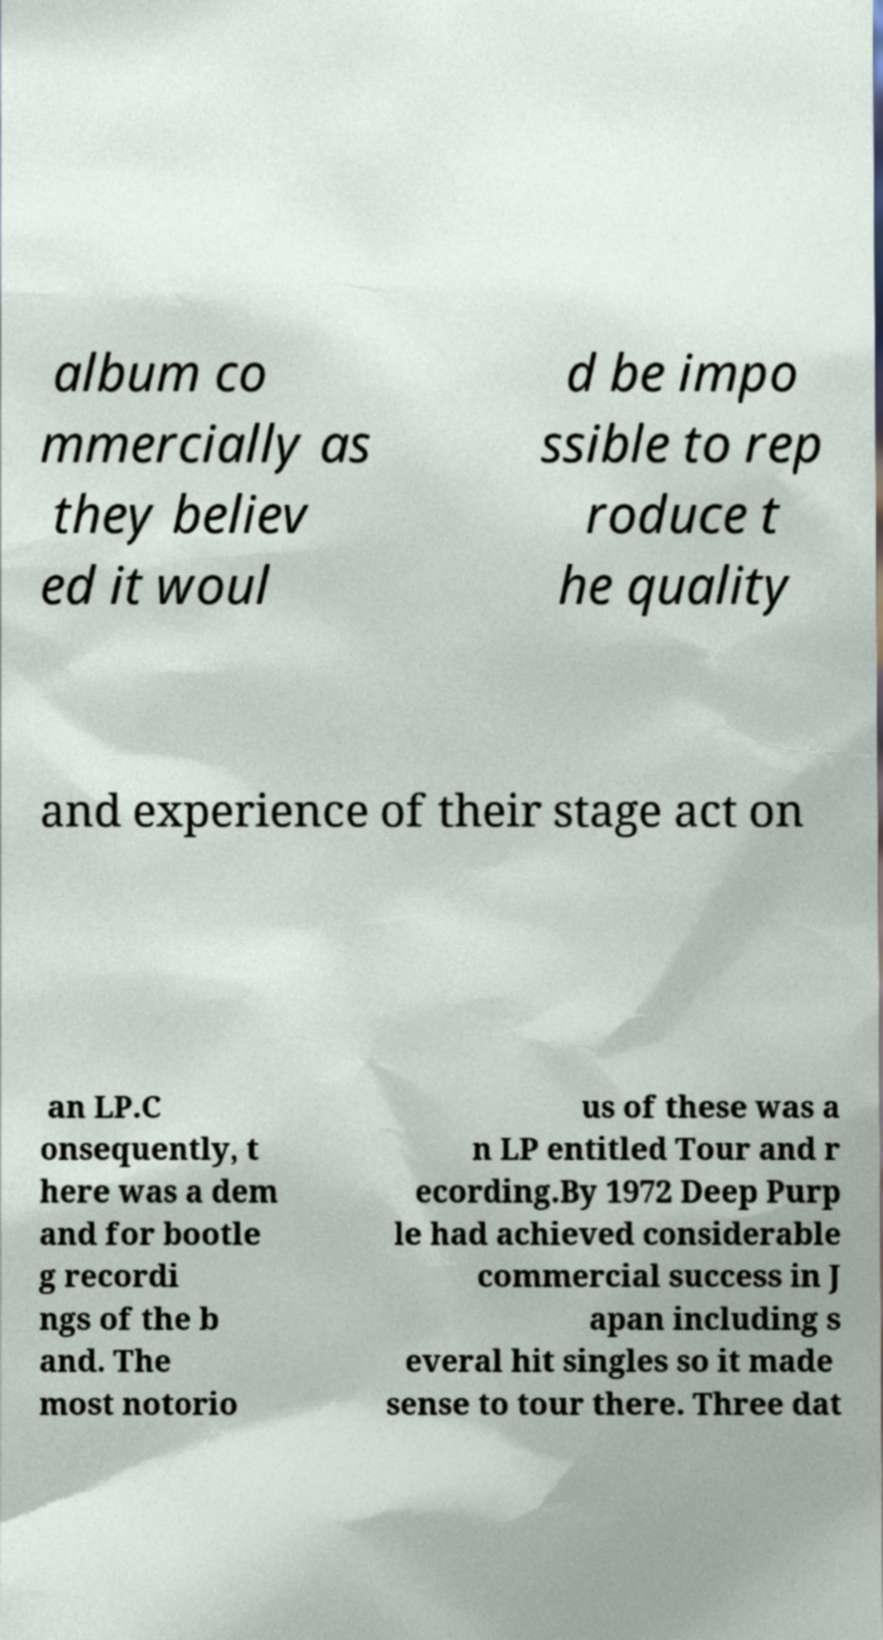Could you extract and type out the text from this image? album co mmercially as they believ ed it woul d be impo ssible to rep roduce t he quality and experience of their stage act on an LP.C onsequently, t here was a dem and for bootle g recordi ngs of the b and. The most notorio us of these was a n LP entitled Tour and r ecording.By 1972 Deep Purp le had achieved considerable commercial success in J apan including s everal hit singles so it made sense to tour there. Three dat 